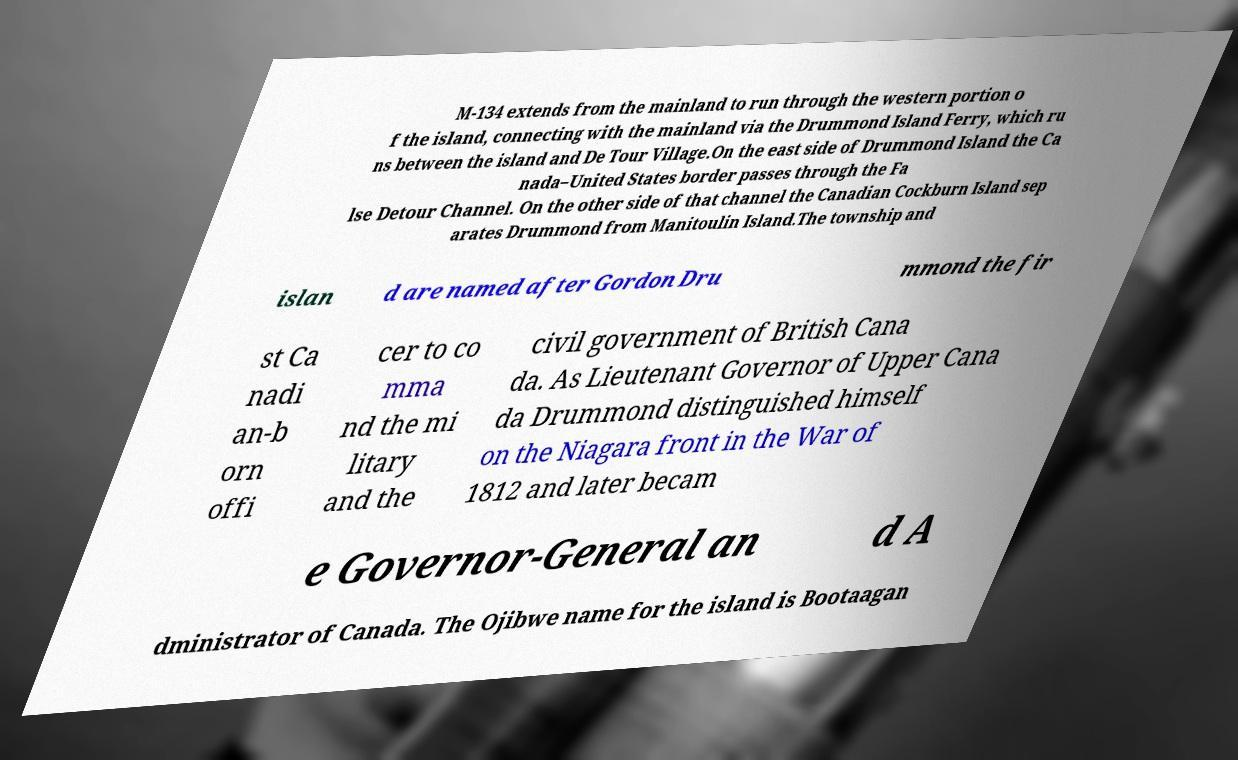I need the written content from this picture converted into text. Can you do that? M-134 extends from the mainland to run through the western portion o f the island, connecting with the mainland via the Drummond Island Ferry, which ru ns between the island and De Tour Village.On the east side of Drummond Island the Ca nada–United States border passes through the Fa lse Detour Channel. On the other side of that channel the Canadian Cockburn Island sep arates Drummond from Manitoulin Island.The township and islan d are named after Gordon Dru mmond the fir st Ca nadi an-b orn offi cer to co mma nd the mi litary and the civil government of British Cana da. As Lieutenant Governor of Upper Cana da Drummond distinguished himself on the Niagara front in the War of 1812 and later becam e Governor-General an d A dministrator of Canada. The Ojibwe name for the island is Bootaagan 